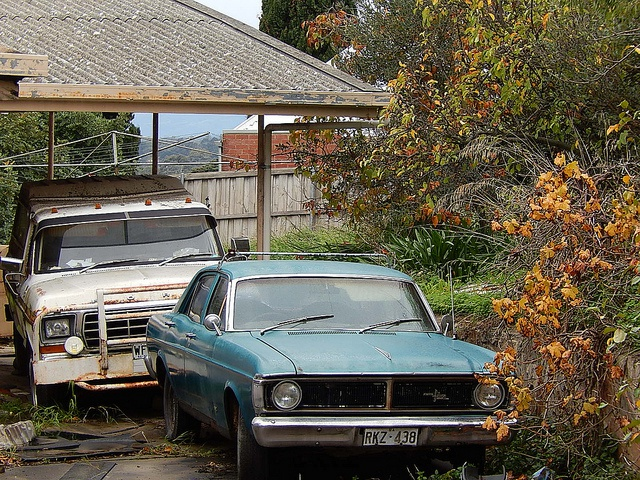Describe the objects in this image and their specific colors. I can see car in darkgray, black, gray, and lightblue tones and truck in darkgray, black, lightgray, and gray tones in this image. 